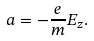<formula> <loc_0><loc_0><loc_500><loc_500>a = - \frac { e } { m } E _ { z } .</formula> 